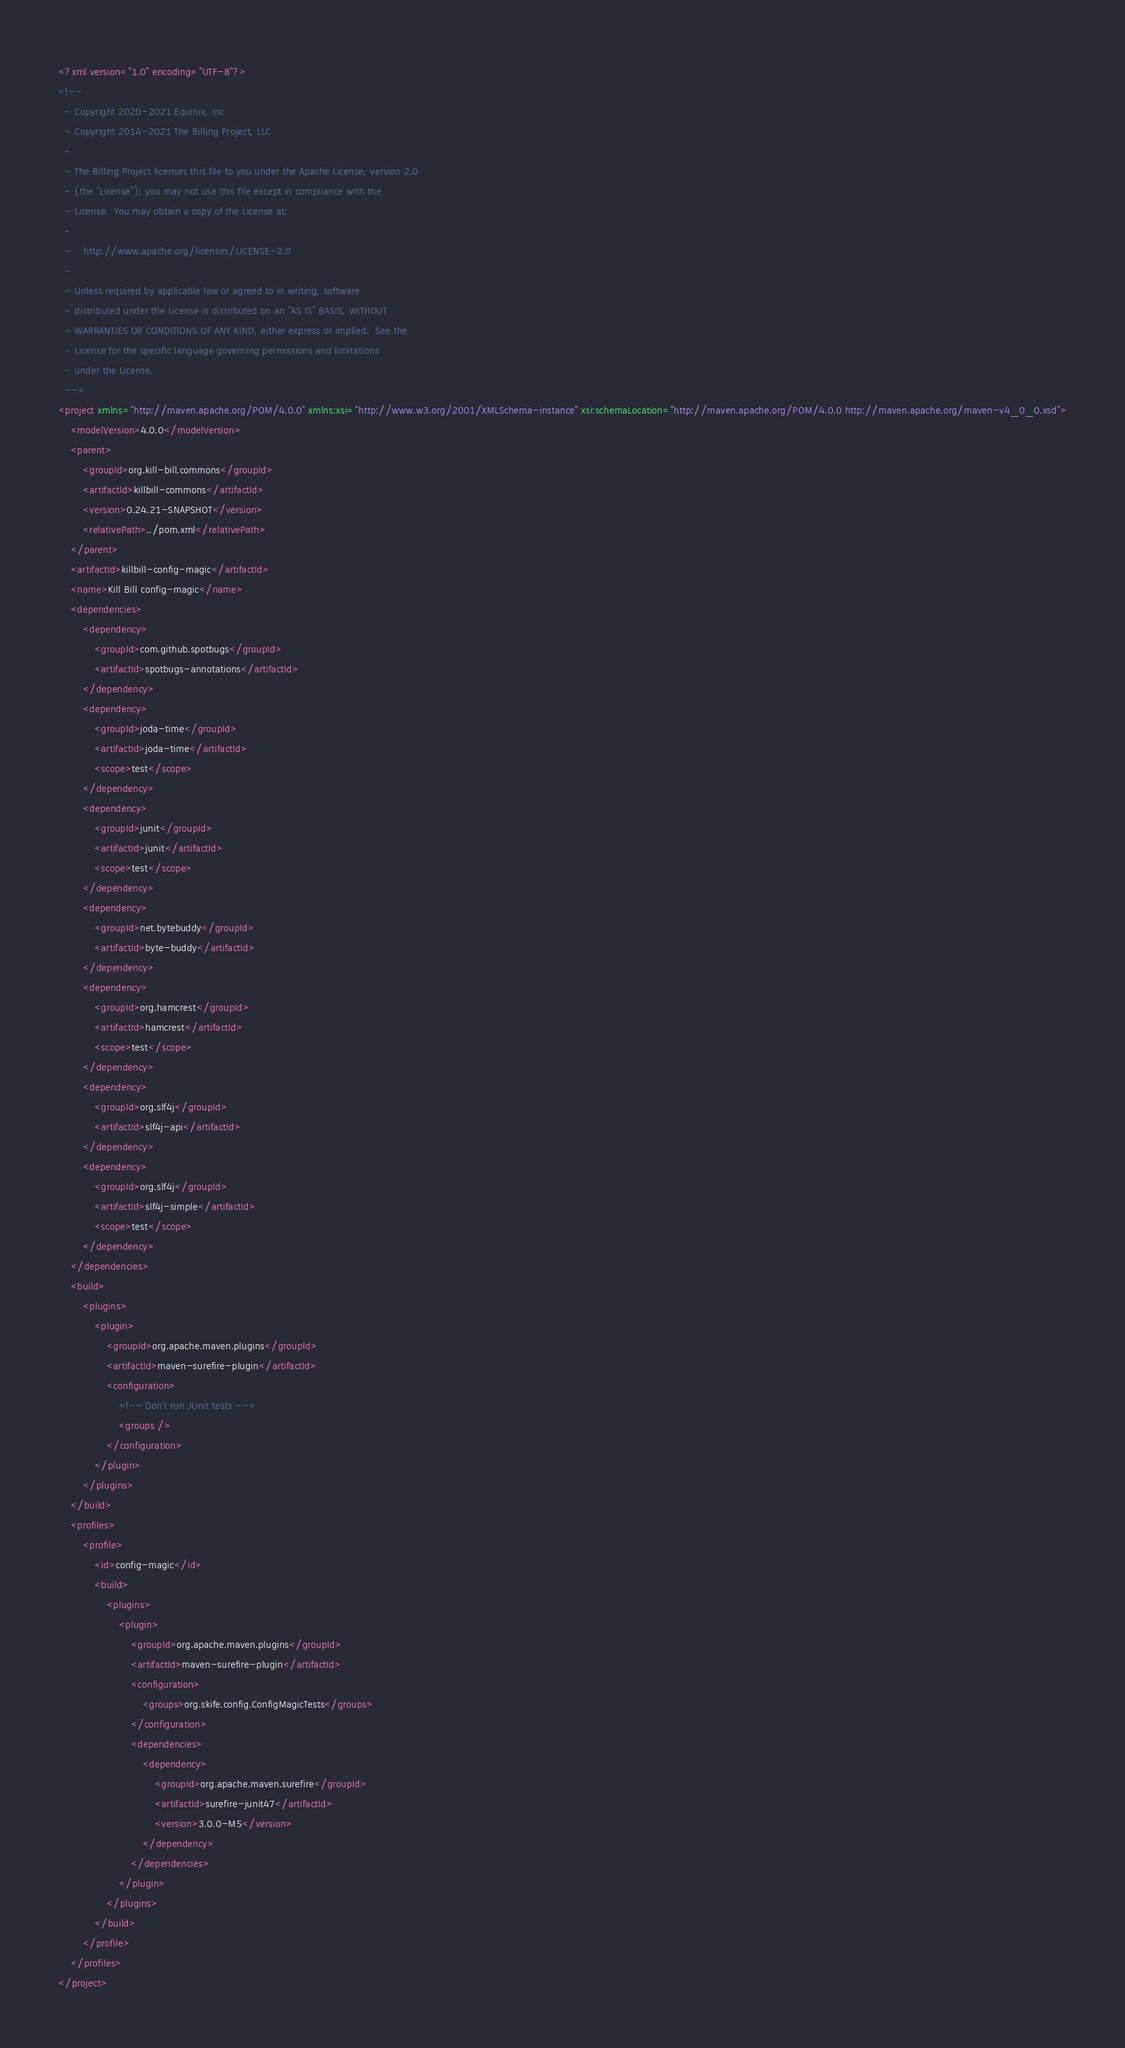<code> <loc_0><loc_0><loc_500><loc_500><_XML_><?xml version="1.0" encoding="UTF-8"?>
<!--
  ~ Copyright 2020-2021 Equinix, Inc
  ~ Copyright 2014-2021 The Billing Project, LLC
  ~
  ~ The Billing Project licenses this file to you under the Apache License, version 2.0
  ~ (the "License"); you may not use this file except in compliance with the
  ~ License.  You may obtain a copy of the License at:
  ~
  ~    http://www.apache.org/licenses/LICENSE-2.0
  ~
  ~ Unless required by applicable law or agreed to in writing, software
  ~ distributed under the License is distributed on an "AS IS" BASIS, WITHOUT
  ~ WARRANTIES OR CONDITIONS OF ANY KIND, either express or implied.  See the
  ~ License for the specific language governing permissions and limitations
  ~ under the License.
  -->
<project xmlns="http://maven.apache.org/POM/4.0.0" xmlns:xsi="http://www.w3.org/2001/XMLSchema-instance" xsi:schemaLocation="http://maven.apache.org/POM/4.0.0 http://maven.apache.org/maven-v4_0_0.xsd">
    <modelVersion>4.0.0</modelVersion>
    <parent>
        <groupId>org.kill-bill.commons</groupId>
        <artifactId>killbill-commons</artifactId>
        <version>0.24.21-SNAPSHOT</version>
        <relativePath>../pom.xml</relativePath>
    </parent>
    <artifactId>killbill-config-magic</artifactId>
    <name>Kill Bill config-magic</name>
    <dependencies>
        <dependency>
            <groupId>com.github.spotbugs</groupId>
            <artifactId>spotbugs-annotations</artifactId>
        </dependency>
        <dependency>
            <groupId>joda-time</groupId>
            <artifactId>joda-time</artifactId>
            <scope>test</scope>
        </dependency>
        <dependency>
            <groupId>junit</groupId>
            <artifactId>junit</artifactId>
            <scope>test</scope>
        </dependency>
        <dependency>
            <groupId>net.bytebuddy</groupId>
            <artifactId>byte-buddy</artifactId>
        </dependency>
        <dependency>
            <groupId>org.hamcrest</groupId>
            <artifactId>hamcrest</artifactId>
            <scope>test</scope>
        </dependency>
        <dependency>
            <groupId>org.slf4j</groupId>
            <artifactId>slf4j-api</artifactId>
        </dependency>
        <dependency>
            <groupId>org.slf4j</groupId>
            <artifactId>slf4j-simple</artifactId>
            <scope>test</scope>
        </dependency>
    </dependencies>
    <build>
        <plugins>
            <plugin>
                <groupId>org.apache.maven.plugins</groupId>
                <artifactId>maven-surefire-plugin</artifactId>
                <configuration>
                    <!-- Don't run JUnit tests -->
                    <groups />
                </configuration>
            </plugin>
        </plugins>
    </build>
    <profiles>
        <profile>
            <id>config-magic</id>
            <build>
                <plugins>
                    <plugin>
                        <groupId>org.apache.maven.plugins</groupId>
                        <artifactId>maven-surefire-plugin</artifactId>
                        <configuration>
                            <groups>org.skife.config.ConfigMagicTests</groups>
                        </configuration>
                        <dependencies>
                            <dependency>
                                <groupId>org.apache.maven.surefire</groupId>
                                <artifactId>surefire-junit47</artifactId>
                                <version>3.0.0-M5</version>
                            </dependency>
                        </dependencies>
                    </plugin>
                </plugins>
            </build>
        </profile>
    </profiles>
</project>
</code> 